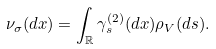Convert formula to latex. <formula><loc_0><loc_0><loc_500><loc_500>\nu _ { \sigma } ( d x ) = \int _ { \mathbb { R } } \gamma _ { s } ^ { ( 2 ) } ( d x ) \rho _ { V } ( d s ) .</formula> 